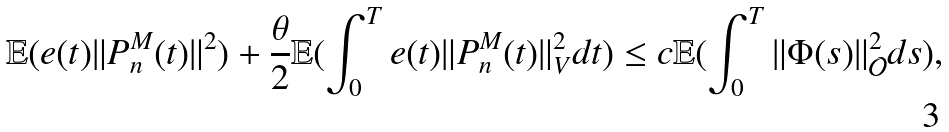Convert formula to latex. <formula><loc_0><loc_0><loc_500><loc_500>\mathbb { E } ( e ( t ) \| P ^ { M } _ { n } ( t ) \| ^ { 2 } ) + \frac { \theta } { 2 } \mathbb { E } ( \int _ { 0 } ^ { T } e ( t ) \| P ^ { M } _ { n } ( t ) \| ^ { 2 } _ { V } d t ) \leq c \mathbb { E } ( \int _ { 0 } ^ { T } \| \Phi ( s ) \| ^ { 2 } _ { \mathcal { O } } d s ) ,</formula> 